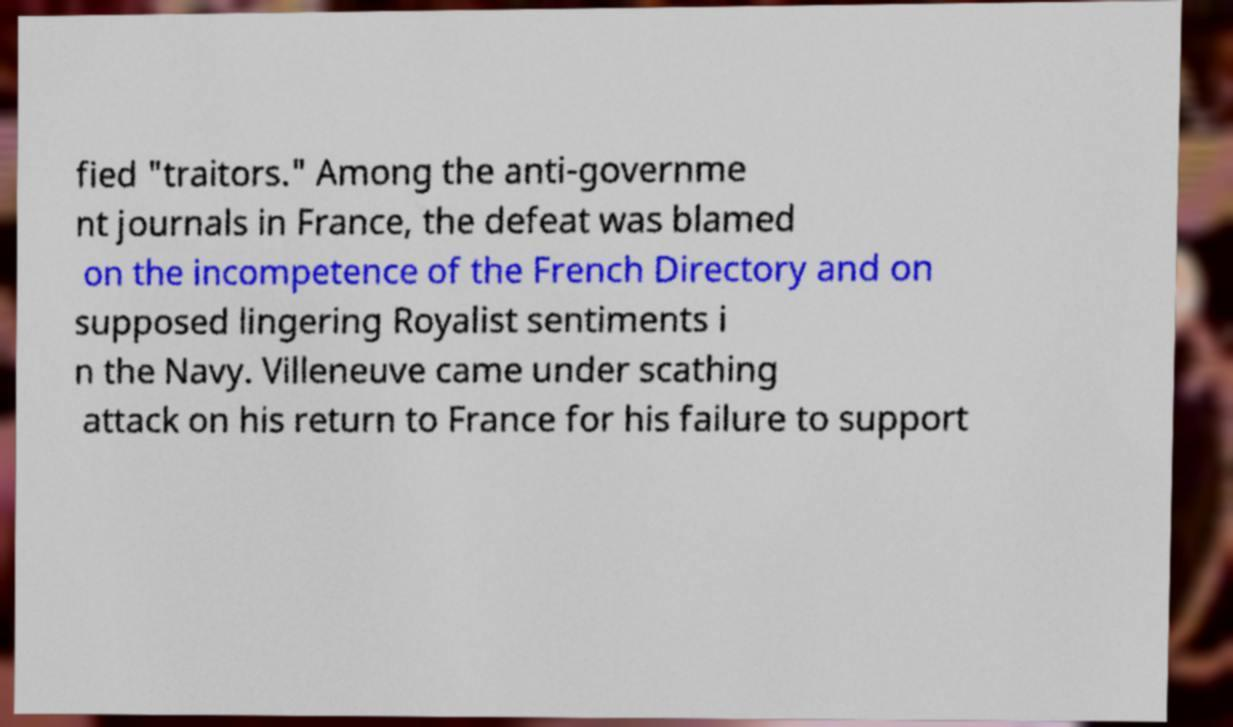Could you extract and type out the text from this image? fied "traitors." Among the anti-governme nt journals in France, the defeat was blamed on the incompetence of the French Directory and on supposed lingering Royalist sentiments i n the Navy. Villeneuve came under scathing attack on his return to France for his failure to support 